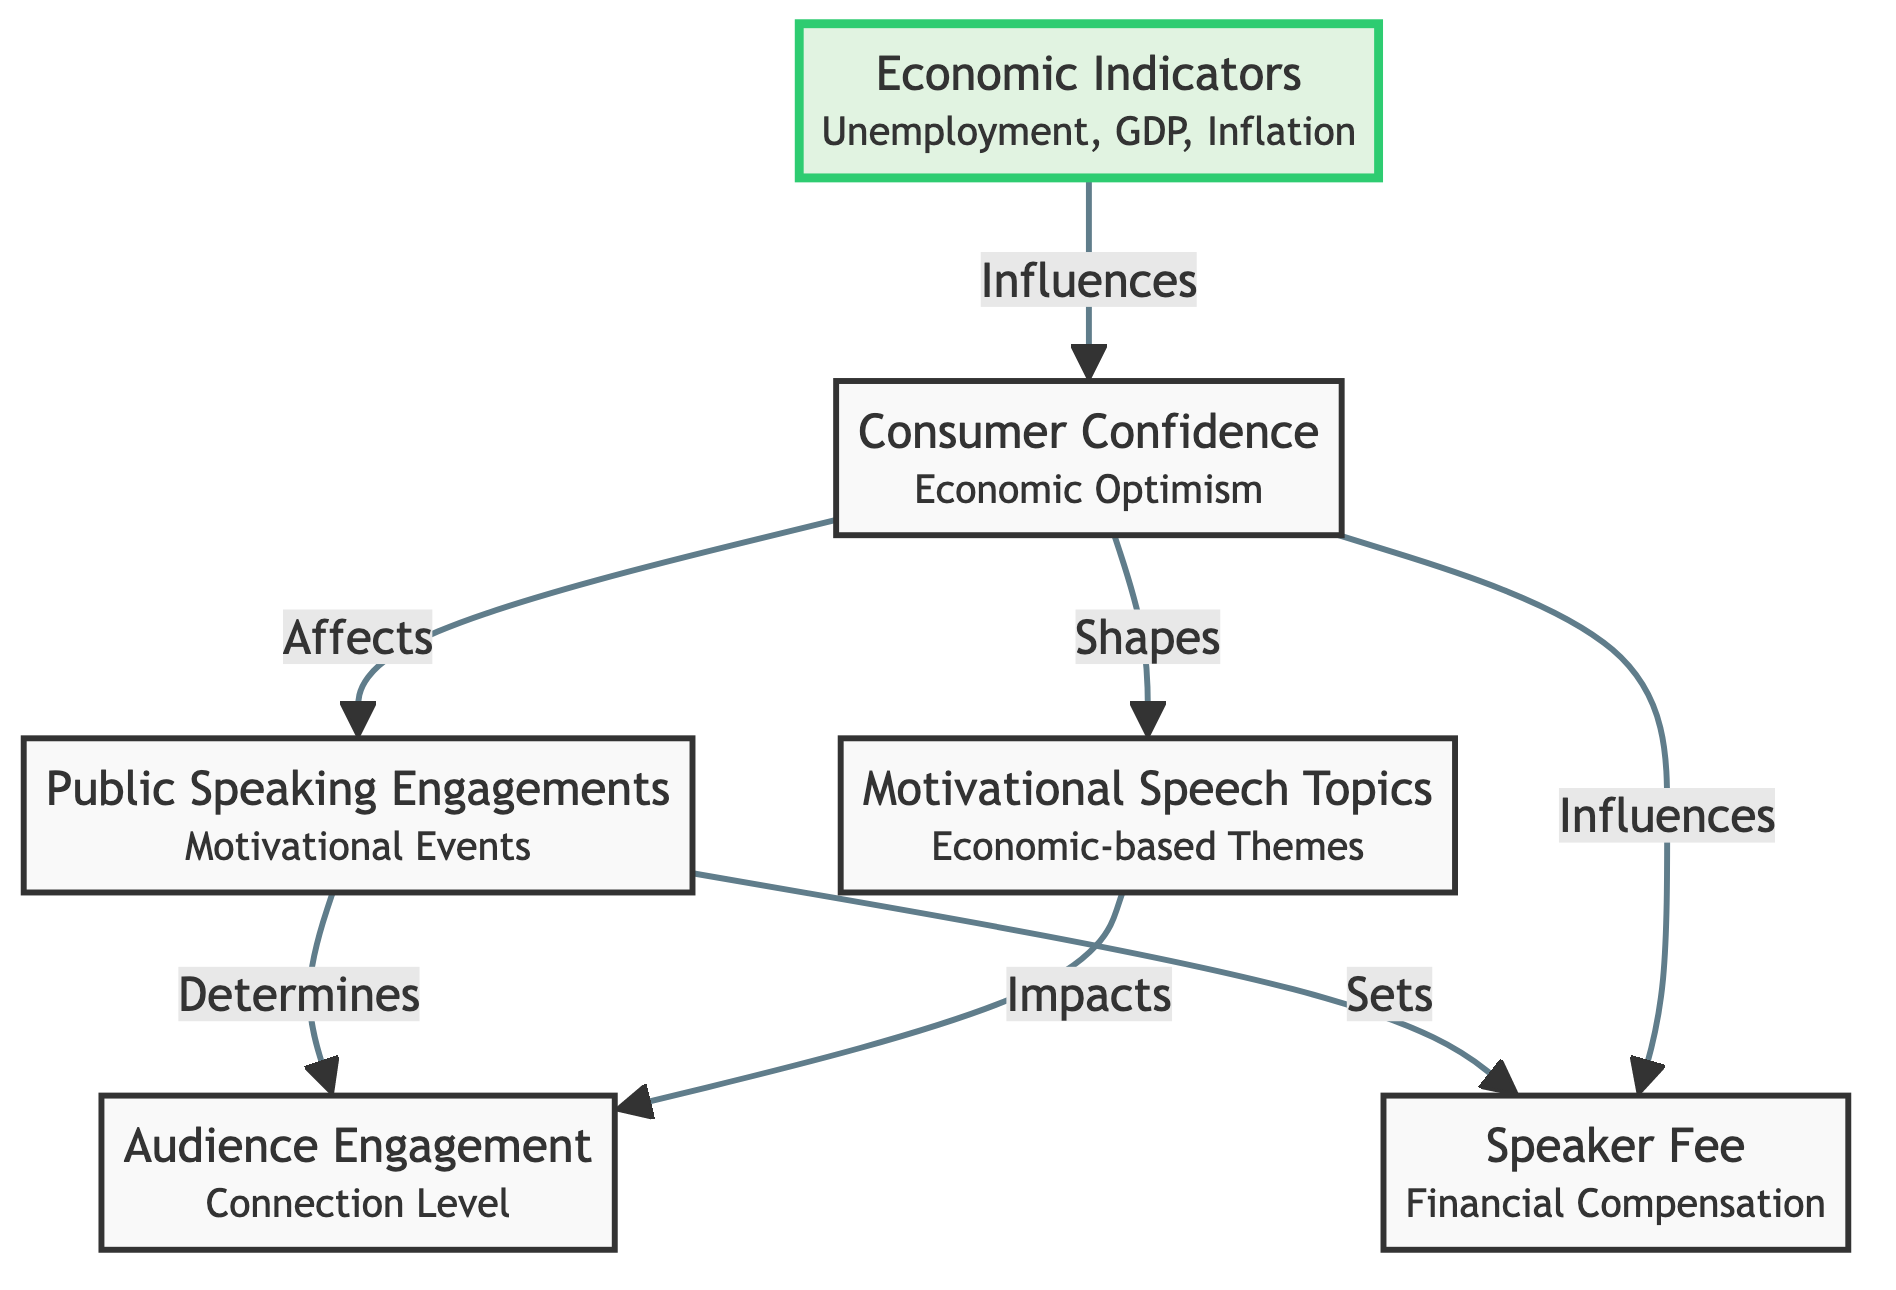What is the primary factor influencing Consumer Confidence? According to the diagram, the primary factor that influences Consumer Confidence is Economic Indicators, as indicated by the direct arrow leading from Economic Indicators to Consumer Confidence.
Answer: Economic Indicators How many nodes are in the diagram? The diagram consists of six nodes: Economic Indicators, Consumer Confidence, Public Speaking Engagements, Motivational Speech Topics, Audience Engagement, and Speaker Fee.
Answer: Six Which element directly affects Audience Engagement? Audience Engagement is directly affected by two elements: Public Speaking Engagements and Motivational Speech Topics, as indicated by the arrows pointing into Audience Engagement from these two nodes.
Answer: Public Speaking Engagements, Motivational Speech Topics What does Consumer Confidence influence? Consumer Confidence influences three elements in the diagram: Public Speaking Engagements, Motivational Speech Topics, and Speaker Fee, all of which have arrows directed from Consumer Confidence.
Answer: Public Speaking Engagements, Motivational Speech Topics, Speaker Fee Which node receives influence from both Consumer Confidence and Economic Indicators? The node that receives influence from both Consumer Confidence and Economic Indicators is Speaker Fee, as indicated by the direct arrows pointing towards Speaker Fee from both nodes.
Answer: Speaker Fee How does Public Speaking Engagements affect Audience Engagement? Public Speaking Engagements impact Audience Engagement by determining it, as represented by the arrow leading from Public Speaking Engagements to Audience Engagement with the label "Determines".
Answer: Determines 